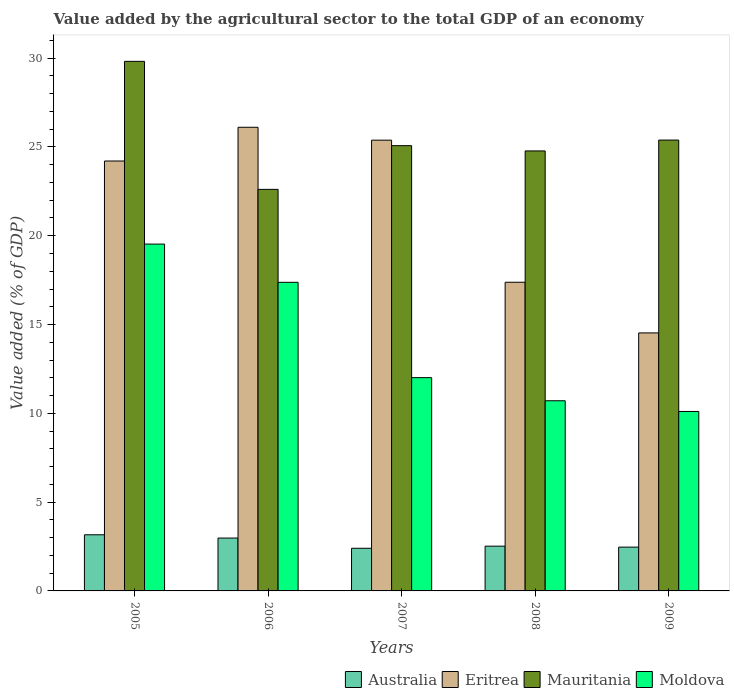How many different coloured bars are there?
Your response must be concise. 4. How many groups of bars are there?
Provide a short and direct response. 5. How many bars are there on the 5th tick from the left?
Offer a very short reply. 4. How many bars are there on the 2nd tick from the right?
Your answer should be very brief. 4. What is the label of the 4th group of bars from the left?
Your answer should be compact. 2008. What is the value added by the agricultural sector to the total GDP in Eritrea in 2005?
Your answer should be very brief. 24.21. Across all years, what is the maximum value added by the agricultural sector to the total GDP in Australia?
Make the answer very short. 3.16. Across all years, what is the minimum value added by the agricultural sector to the total GDP in Mauritania?
Keep it short and to the point. 22.61. In which year was the value added by the agricultural sector to the total GDP in Eritrea minimum?
Ensure brevity in your answer.  2009. What is the total value added by the agricultural sector to the total GDP in Moldova in the graph?
Your response must be concise. 69.73. What is the difference between the value added by the agricultural sector to the total GDP in Eritrea in 2007 and that in 2009?
Your answer should be compact. 10.85. What is the difference between the value added by the agricultural sector to the total GDP in Australia in 2008 and the value added by the agricultural sector to the total GDP in Moldova in 2005?
Provide a short and direct response. -17.01. What is the average value added by the agricultural sector to the total GDP in Australia per year?
Provide a short and direct response. 2.71. In the year 2009, what is the difference between the value added by the agricultural sector to the total GDP in Eritrea and value added by the agricultural sector to the total GDP in Moldova?
Your answer should be compact. 4.42. In how many years, is the value added by the agricultural sector to the total GDP in Australia greater than 15 %?
Your response must be concise. 0. What is the ratio of the value added by the agricultural sector to the total GDP in Moldova in 2007 to that in 2009?
Give a very brief answer. 1.19. Is the value added by the agricultural sector to the total GDP in Mauritania in 2007 less than that in 2008?
Your answer should be compact. No. What is the difference between the highest and the second highest value added by the agricultural sector to the total GDP in Eritrea?
Keep it short and to the point. 0.73. What is the difference between the highest and the lowest value added by the agricultural sector to the total GDP in Moldova?
Provide a short and direct response. 9.43. In how many years, is the value added by the agricultural sector to the total GDP in Australia greater than the average value added by the agricultural sector to the total GDP in Australia taken over all years?
Offer a terse response. 2. What does the 2nd bar from the left in 2007 represents?
Offer a very short reply. Eritrea. What does the 3rd bar from the right in 2005 represents?
Your answer should be very brief. Eritrea. Is it the case that in every year, the sum of the value added by the agricultural sector to the total GDP in Eritrea and value added by the agricultural sector to the total GDP in Australia is greater than the value added by the agricultural sector to the total GDP in Moldova?
Your response must be concise. Yes. What is the difference between two consecutive major ticks on the Y-axis?
Your response must be concise. 5. Does the graph contain grids?
Ensure brevity in your answer.  No. Where does the legend appear in the graph?
Ensure brevity in your answer.  Bottom right. How are the legend labels stacked?
Your answer should be very brief. Horizontal. What is the title of the graph?
Give a very brief answer. Value added by the agricultural sector to the total GDP of an economy. Does "Liechtenstein" appear as one of the legend labels in the graph?
Your response must be concise. No. What is the label or title of the Y-axis?
Make the answer very short. Value added (% of GDP). What is the Value added (% of GDP) in Australia in 2005?
Your response must be concise. 3.16. What is the Value added (% of GDP) in Eritrea in 2005?
Your answer should be compact. 24.21. What is the Value added (% of GDP) of Mauritania in 2005?
Your answer should be compact. 29.82. What is the Value added (% of GDP) of Moldova in 2005?
Your answer should be compact. 19.53. What is the Value added (% of GDP) in Australia in 2006?
Provide a short and direct response. 2.98. What is the Value added (% of GDP) of Eritrea in 2006?
Give a very brief answer. 26.11. What is the Value added (% of GDP) in Mauritania in 2006?
Provide a succinct answer. 22.61. What is the Value added (% of GDP) in Moldova in 2006?
Keep it short and to the point. 17.38. What is the Value added (% of GDP) of Australia in 2007?
Keep it short and to the point. 2.4. What is the Value added (% of GDP) in Eritrea in 2007?
Provide a short and direct response. 25.38. What is the Value added (% of GDP) in Mauritania in 2007?
Give a very brief answer. 25.07. What is the Value added (% of GDP) in Moldova in 2007?
Provide a short and direct response. 12.01. What is the Value added (% of GDP) of Australia in 2008?
Keep it short and to the point. 2.52. What is the Value added (% of GDP) in Eritrea in 2008?
Offer a very short reply. 17.38. What is the Value added (% of GDP) in Mauritania in 2008?
Offer a terse response. 24.78. What is the Value added (% of GDP) in Moldova in 2008?
Provide a short and direct response. 10.71. What is the Value added (% of GDP) of Australia in 2009?
Your response must be concise. 2.47. What is the Value added (% of GDP) of Eritrea in 2009?
Offer a very short reply. 14.53. What is the Value added (% of GDP) of Mauritania in 2009?
Provide a short and direct response. 25.39. What is the Value added (% of GDP) in Moldova in 2009?
Your response must be concise. 10.11. Across all years, what is the maximum Value added (% of GDP) in Australia?
Keep it short and to the point. 3.16. Across all years, what is the maximum Value added (% of GDP) of Eritrea?
Offer a terse response. 26.11. Across all years, what is the maximum Value added (% of GDP) of Mauritania?
Make the answer very short. 29.82. Across all years, what is the maximum Value added (% of GDP) in Moldova?
Offer a very short reply. 19.53. Across all years, what is the minimum Value added (% of GDP) of Australia?
Offer a very short reply. 2.4. Across all years, what is the minimum Value added (% of GDP) in Eritrea?
Offer a terse response. 14.53. Across all years, what is the minimum Value added (% of GDP) in Mauritania?
Your response must be concise. 22.61. Across all years, what is the minimum Value added (% of GDP) of Moldova?
Offer a very short reply. 10.11. What is the total Value added (% of GDP) of Australia in the graph?
Your answer should be very brief. 13.53. What is the total Value added (% of GDP) in Eritrea in the graph?
Keep it short and to the point. 107.61. What is the total Value added (% of GDP) of Mauritania in the graph?
Provide a short and direct response. 127.67. What is the total Value added (% of GDP) in Moldova in the graph?
Your answer should be very brief. 69.73. What is the difference between the Value added (% of GDP) in Australia in 2005 and that in 2006?
Provide a succinct answer. 0.18. What is the difference between the Value added (% of GDP) in Eritrea in 2005 and that in 2006?
Offer a terse response. -1.9. What is the difference between the Value added (% of GDP) in Mauritania in 2005 and that in 2006?
Your response must be concise. 7.21. What is the difference between the Value added (% of GDP) in Moldova in 2005 and that in 2006?
Give a very brief answer. 2.15. What is the difference between the Value added (% of GDP) in Australia in 2005 and that in 2007?
Your answer should be compact. 0.76. What is the difference between the Value added (% of GDP) of Eritrea in 2005 and that in 2007?
Offer a terse response. -1.17. What is the difference between the Value added (% of GDP) of Mauritania in 2005 and that in 2007?
Provide a succinct answer. 4.75. What is the difference between the Value added (% of GDP) in Moldova in 2005 and that in 2007?
Make the answer very short. 7.52. What is the difference between the Value added (% of GDP) in Australia in 2005 and that in 2008?
Make the answer very short. 0.64. What is the difference between the Value added (% of GDP) in Eritrea in 2005 and that in 2008?
Your answer should be very brief. 6.83. What is the difference between the Value added (% of GDP) in Mauritania in 2005 and that in 2008?
Make the answer very short. 5.04. What is the difference between the Value added (% of GDP) in Moldova in 2005 and that in 2008?
Provide a succinct answer. 8.82. What is the difference between the Value added (% of GDP) of Australia in 2005 and that in 2009?
Ensure brevity in your answer.  0.69. What is the difference between the Value added (% of GDP) in Eritrea in 2005 and that in 2009?
Give a very brief answer. 9.68. What is the difference between the Value added (% of GDP) of Mauritania in 2005 and that in 2009?
Provide a short and direct response. 4.43. What is the difference between the Value added (% of GDP) in Moldova in 2005 and that in 2009?
Provide a succinct answer. 9.43. What is the difference between the Value added (% of GDP) in Australia in 2006 and that in 2007?
Give a very brief answer. 0.58. What is the difference between the Value added (% of GDP) in Eritrea in 2006 and that in 2007?
Provide a succinct answer. 0.73. What is the difference between the Value added (% of GDP) of Mauritania in 2006 and that in 2007?
Offer a very short reply. -2.46. What is the difference between the Value added (% of GDP) of Moldova in 2006 and that in 2007?
Your answer should be compact. 5.37. What is the difference between the Value added (% of GDP) in Australia in 2006 and that in 2008?
Your answer should be compact. 0.46. What is the difference between the Value added (% of GDP) of Eritrea in 2006 and that in 2008?
Offer a very short reply. 8.73. What is the difference between the Value added (% of GDP) in Mauritania in 2006 and that in 2008?
Give a very brief answer. -2.16. What is the difference between the Value added (% of GDP) in Moldova in 2006 and that in 2008?
Keep it short and to the point. 6.67. What is the difference between the Value added (% of GDP) in Australia in 2006 and that in 2009?
Provide a succinct answer. 0.51. What is the difference between the Value added (% of GDP) of Eritrea in 2006 and that in 2009?
Offer a terse response. 11.58. What is the difference between the Value added (% of GDP) of Mauritania in 2006 and that in 2009?
Provide a succinct answer. -2.78. What is the difference between the Value added (% of GDP) in Moldova in 2006 and that in 2009?
Your answer should be compact. 7.27. What is the difference between the Value added (% of GDP) of Australia in 2007 and that in 2008?
Provide a short and direct response. -0.12. What is the difference between the Value added (% of GDP) in Eritrea in 2007 and that in 2008?
Your answer should be compact. 8. What is the difference between the Value added (% of GDP) of Mauritania in 2007 and that in 2008?
Your response must be concise. 0.3. What is the difference between the Value added (% of GDP) in Moldova in 2007 and that in 2008?
Ensure brevity in your answer.  1.3. What is the difference between the Value added (% of GDP) of Australia in 2007 and that in 2009?
Your answer should be compact. -0.07. What is the difference between the Value added (% of GDP) of Eritrea in 2007 and that in 2009?
Give a very brief answer. 10.85. What is the difference between the Value added (% of GDP) in Mauritania in 2007 and that in 2009?
Provide a short and direct response. -0.32. What is the difference between the Value added (% of GDP) in Moldova in 2007 and that in 2009?
Provide a short and direct response. 1.9. What is the difference between the Value added (% of GDP) in Australia in 2008 and that in 2009?
Your response must be concise. 0.05. What is the difference between the Value added (% of GDP) in Eritrea in 2008 and that in 2009?
Keep it short and to the point. 2.85. What is the difference between the Value added (% of GDP) in Mauritania in 2008 and that in 2009?
Your answer should be very brief. -0.61. What is the difference between the Value added (% of GDP) of Moldova in 2008 and that in 2009?
Your response must be concise. 0.6. What is the difference between the Value added (% of GDP) in Australia in 2005 and the Value added (% of GDP) in Eritrea in 2006?
Provide a short and direct response. -22.95. What is the difference between the Value added (% of GDP) of Australia in 2005 and the Value added (% of GDP) of Mauritania in 2006?
Provide a short and direct response. -19.45. What is the difference between the Value added (% of GDP) of Australia in 2005 and the Value added (% of GDP) of Moldova in 2006?
Offer a terse response. -14.22. What is the difference between the Value added (% of GDP) in Eritrea in 2005 and the Value added (% of GDP) in Mauritania in 2006?
Offer a very short reply. 1.6. What is the difference between the Value added (% of GDP) of Eritrea in 2005 and the Value added (% of GDP) of Moldova in 2006?
Your answer should be compact. 6.83. What is the difference between the Value added (% of GDP) of Mauritania in 2005 and the Value added (% of GDP) of Moldova in 2006?
Keep it short and to the point. 12.44. What is the difference between the Value added (% of GDP) in Australia in 2005 and the Value added (% of GDP) in Eritrea in 2007?
Offer a very short reply. -22.22. What is the difference between the Value added (% of GDP) in Australia in 2005 and the Value added (% of GDP) in Mauritania in 2007?
Your answer should be very brief. -21.91. What is the difference between the Value added (% of GDP) of Australia in 2005 and the Value added (% of GDP) of Moldova in 2007?
Make the answer very short. -8.85. What is the difference between the Value added (% of GDP) of Eritrea in 2005 and the Value added (% of GDP) of Mauritania in 2007?
Give a very brief answer. -0.86. What is the difference between the Value added (% of GDP) in Eritrea in 2005 and the Value added (% of GDP) in Moldova in 2007?
Give a very brief answer. 12.2. What is the difference between the Value added (% of GDP) of Mauritania in 2005 and the Value added (% of GDP) of Moldova in 2007?
Provide a succinct answer. 17.81. What is the difference between the Value added (% of GDP) of Australia in 2005 and the Value added (% of GDP) of Eritrea in 2008?
Keep it short and to the point. -14.22. What is the difference between the Value added (% of GDP) of Australia in 2005 and the Value added (% of GDP) of Mauritania in 2008?
Provide a succinct answer. -21.62. What is the difference between the Value added (% of GDP) in Australia in 2005 and the Value added (% of GDP) in Moldova in 2008?
Your answer should be very brief. -7.55. What is the difference between the Value added (% of GDP) of Eritrea in 2005 and the Value added (% of GDP) of Mauritania in 2008?
Your response must be concise. -0.57. What is the difference between the Value added (% of GDP) in Eritrea in 2005 and the Value added (% of GDP) in Moldova in 2008?
Provide a short and direct response. 13.5. What is the difference between the Value added (% of GDP) in Mauritania in 2005 and the Value added (% of GDP) in Moldova in 2008?
Give a very brief answer. 19.11. What is the difference between the Value added (% of GDP) of Australia in 2005 and the Value added (% of GDP) of Eritrea in 2009?
Your answer should be compact. -11.37. What is the difference between the Value added (% of GDP) of Australia in 2005 and the Value added (% of GDP) of Mauritania in 2009?
Your response must be concise. -22.23. What is the difference between the Value added (% of GDP) in Australia in 2005 and the Value added (% of GDP) in Moldova in 2009?
Make the answer very short. -6.94. What is the difference between the Value added (% of GDP) of Eritrea in 2005 and the Value added (% of GDP) of Mauritania in 2009?
Keep it short and to the point. -1.18. What is the difference between the Value added (% of GDP) in Eritrea in 2005 and the Value added (% of GDP) in Moldova in 2009?
Ensure brevity in your answer.  14.1. What is the difference between the Value added (% of GDP) of Mauritania in 2005 and the Value added (% of GDP) of Moldova in 2009?
Ensure brevity in your answer.  19.72. What is the difference between the Value added (% of GDP) in Australia in 2006 and the Value added (% of GDP) in Eritrea in 2007?
Provide a short and direct response. -22.41. What is the difference between the Value added (% of GDP) of Australia in 2006 and the Value added (% of GDP) of Mauritania in 2007?
Keep it short and to the point. -22.1. What is the difference between the Value added (% of GDP) in Australia in 2006 and the Value added (% of GDP) in Moldova in 2007?
Your response must be concise. -9.03. What is the difference between the Value added (% of GDP) of Eritrea in 2006 and the Value added (% of GDP) of Mauritania in 2007?
Offer a terse response. 1.04. What is the difference between the Value added (% of GDP) of Eritrea in 2006 and the Value added (% of GDP) of Moldova in 2007?
Give a very brief answer. 14.1. What is the difference between the Value added (% of GDP) in Mauritania in 2006 and the Value added (% of GDP) in Moldova in 2007?
Your response must be concise. 10.6. What is the difference between the Value added (% of GDP) in Australia in 2006 and the Value added (% of GDP) in Eritrea in 2008?
Your response must be concise. -14.41. What is the difference between the Value added (% of GDP) of Australia in 2006 and the Value added (% of GDP) of Mauritania in 2008?
Give a very brief answer. -21.8. What is the difference between the Value added (% of GDP) in Australia in 2006 and the Value added (% of GDP) in Moldova in 2008?
Keep it short and to the point. -7.73. What is the difference between the Value added (% of GDP) in Eritrea in 2006 and the Value added (% of GDP) in Mauritania in 2008?
Provide a short and direct response. 1.33. What is the difference between the Value added (% of GDP) in Eritrea in 2006 and the Value added (% of GDP) in Moldova in 2008?
Your answer should be very brief. 15.4. What is the difference between the Value added (% of GDP) of Mauritania in 2006 and the Value added (% of GDP) of Moldova in 2008?
Ensure brevity in your answer.  11.9. What is the difference between the Value added (% of GDP) in Australia in 2006 and the Value added (% of GDP) in Eritrea in 2009?
Provide a succinct answer. -11.55. What is the difference between the Value added (% of GDP) of Australia in 2006 and the Value added (% of GDP) of Mauritania in 2009?
Keep it short and to the point. -22.41. What is the difference between the Value added (% of GDP) in Australia in 2006 and the Value added (% of GDP) in Moldova in 2009?
Make the answer very short. -7.13. What is the difference between the Value added (% of GDP) of Eritrea in 2006 and the Value added (% of GDP) of Mauritania in 2009?
Give a very brief answer. 0.72. What is the difference between the Value added (% of GDP) of Eritrea in 2006 and the Value added (% of GDP) of Moldova in 2009?
Ensure brevity in your answer.  16. What is the difference between the Value added (% of GDP) of Mauritania in 2006 and the Value added (% of GDP) of Moldova in 2009?
Provide a short and direct response. 12.51. What is the difference between the Value added (% of GDP) of Australia in 2007 and the Value added (% of GDP) of Eritrea in 2008?
Provide a succinct answer. -14.98. What is the difference between the Value added (% of GDP) of Australia in 2007 and the Value added (% of GDP) of Mauritania in 2008?
Provide a short and direct response. -22.38. What is the difference between the Value added (% of GDP) of Australia in 2007 and the Value added (% of GDP) of Moldova in 2008?
Ensure brevity in your answer.  -8.31. What is the difference between the Value added (% of GDP) of Eritrea in 2007 and the Value added (% of GDP) of Mauritania in 2008?
Your answer should be compact. 0.61. What is the difference between the Value added (% of GDP) of Eritrea in 2007 and the Value added (% of GDP) of Moldova in 2008?
Give a very brief answer. 14.68. What is the difference between the Value added (% of GDP) of Mauritania in 2007 and the Value added (% of GDP) of Moldova in 2008?
Your answer should be very brief. 14.37. What is the difference between the Value added (% of GDP) of Australia in 2007 and the Value added (% of GDP) of Eritrea in 2009?
Offer a very short reply. -12.13. What is the difference between the Value added (% of GDP) of Australia in 2007 and the Value added (% of GDP) of Mauritania in 2009?
Provide a succinct answer. -22.99. What is the difference between the Value added (% of GDP) of Australia in 2007 and the Value added (% of GDP) of Moldova in 2009?
Ensure brevity in your answer.  -7.7. What is the difference between the Value added (% of GDP) of Eritrea in 2007 and the Value added (% of GDP) of Mauritania in 2009?
Give a very brief answer. -0. What is the difference between the Value added (% of GDP) in Eritrea in 2007 and the Value added (% of GDP) in Moldova in 2009?
Offer a terse response. 15.28. What is the difference between the Value added (% of GDP) of Mauritania in 2007 and the Value added (% of GDP) of Moldova in 2009?
Provide a short and direct response. 14.97. What is the difference between the Value added (% of GDP) of Australia in 2008 and the Value added (% of GDP) of Eritrea in 2009?
Offer a very short reply. -12.01. What is the difference between the Value added (% of GDP) in Australia in 2008 and the Value added (% of GDP) in Mauritania in 2009?
Offer a terse response. -22.87. What is the difference between the Value added (% of GDP) of Australia in 2008 and the Value added (% of GDP) of Moldova in 2009?
Give a very brief answer. -7.59. What is the difference between the Value added (% of GDP) in Eritrea in 2008 and the Value added (% of GDP) in Mauritania in 2009?
Offer a very short reply. -8.01. What is the difference between the Value added (% of GDP) in Eritrea in 2008 and the Value added (% of GDP) in Moldova in 2009?
Keep it short and to the point. 7.28. What is the difference between the Value added (% of GDP) of Mauritania in 2008 and the Value added (% of GDP) of Moldova in 2009?
Offer a very short reply. 14.67. What is the average Value added (% of GDP) in Australia per year?
Keep it short and to the point. 2.71. What is the average Value added (% of GDP) in Eritrea per year?
Make the answer very short. 21.52. What is the average Value added (% of GDP) of Mauritania per year?
Provide a short and direct response. 25.53. What is the average Value added (% of GDP) of Moldova per year?
Provide a short and direct response. 13.95. In the year 2005, what is the difference between the Value added (% of GDP) of Australia and Value added (% of GDP) of Eritrea?
Your answer should be very brief. -21.05. In the year 2005, what is the difference between the Value added (% of GDP) in Australia and Value added (% of GDP) in Mauritania?
Your answer should be very brief. -26.66. In the year 2005, what is the difference between the Value added (% of GDP) in Australia and Value added (% of GDP) in Moldova?
Your response must be concise. -16.37. In the year 2005, what is the difference between the Value added (% of GDP) of Eritrea and Value added (% of GDP) of Mauritania?
Your answer should be compact. -5.61. In the year 2005, what is the difference between the Value added (% of GDP) of Eritrea and Value added (% of GDP) of Moldova?
Provide a succinct answer. 4.68. In the year 2005, what is the difference between the Value added (% of GDP) in Mauritania and Value added (% of GDP) in Moldova?
Your answer should be very brief. 10.29. In the year 2006, what is the difference between the Value added (% of GDP) of Australia and Value added (% of GDP) of Eritrea?
Your response must be concise. -23.13. In the year 2006, what is the difference between the Value added (% of GDP) in Australia and Value added (% of GDP) in Mauritania?
Keep it short and to the point. -19.64. In the year 2006, what is the difference between the Value added (% of GDP) in Australia and Value added (% of GDP) in Moldova?
Offer a very short reply. -14.4. In the year 2006, what is the difference between the Value added (% of GDP) in Eritrea and Value added (% of GDP) in Mauritania?
Your answer should be very brief. 3.5. In the year 2006, what is the difference between the Value added (% of GDP) of Eritrea and Value added (% of GDP) of Moldova?
Provide a succinct answer. 8.73. In the year 2006, what is the difference between the Value added (% of GDP) of Mauritania and Value added (% of GDP) of Moldova?
Make the answer very short. 5.23. In the year 2007, what is the difference between the Value added (% of GDP) of Australia and Value added (% of GDP) of Eritrea?
Ensure brevity in your answer.  -22.98. In the year 2007, what is the difference between the Value added (% of GDP) of Australia and Value added (% of GDP) of Mauritania?
Offer a terse response. -22.67. In the year 2007, what is the difference between the Value added (% of GDP) of Australia and Value added (% of GDP) of Moldova?
Provide a short and direct response. -9.61. In the year 2007, what is the difference between the Value added (% of GDP) in Eritrea and Value added (% of GDP) in Mauritania?
Provide a short and direct response. 0.31. In the year 2007, what is the difference between the Value added (% of GDP) in Eritrea and Value added (% of GDP) in Moldova?
Provide a succinct answer. 13.37. In the year 2007, what is the difference between the Value added (% of GDP) in Mauritania and Value added (% of GDP) in Moldova?
Ensure brevity in your answer.  13.06. In the year 2008, what is the difference between the Value added (% of GDP) of Australia and Value added (% of GDP) of Eritrea?
Give a very brief answer. -14.86. In the year 2008, what is the difference between the Value added (% of GDP) in Australia and Value added (% of GDP) in Mauritania?
Keep it short and to the point. -22.26. In the year 2008, what is the difference between the Value added (% of GDP) of Australia and Value added (% of GDP) of Moldova?
Keep it short and to the point. -8.19. In the year 2008, what is the difference between the Value added (% of GDP) of Eritrea and Value added (% of GDP) of Mauritania?
Provide a succinct answer. -7.39. In the year 2008, what is the difference between the Value added (% of GDP) in Eritrea and Value added (% of GDP) in Moldova?
Make the answer very short. 6.67. In the year 2008, what is the difference between the Value added (% of GDP) of Mauritania and Value added (% of GDP) of Moldova?
Your response must be concise. 14.07. In the year 2009, what is the difference between the Value added (% of GDP) in Australia and Value added (% of GDP) in Eritrea?
Your answer should be compact. -12.06. In the year 2009, what is the difference between the Value added (% of GDP) of Australia and Value added (% of GDP) of Mauritania?
Your response must be concise. -22.92. In the year 2009, what is the difference between the Value added (% of GDP) of Australia and Value added (% of GDP) of Moldova?
Provide a short and direct response. -7.64. In the year 2009, what is the difference between the Value added (% of GDP) of Eritrea and Value added (% of GDP) of Mauritania?
Your answer should be compact. -10.86. In the year 2009, what is the difference between the Value added (% of GDP) in Eritrea and Value added (% of GDP) in Moldova?
Your answer should be very brief. 4.42. In the year 2009, what is the difference between the Value added (% of GDP) in Mauritania and Value added (% of GDP) in Moldova?
Ensure brevity in your answer.  15.28. What is the ratio of the Value added (% of GDP) of Australia in 2005 to that in 2006?
Offer a terse response. 1.06. What is the ratio of the Value added (% of GDP) in Eritrea in 2005 to that in 2006?
Offer a very short reply. 0.93. What is the ratio of the Value added (% of GDP) in Mauritania in 2005 to that in 2006?
Provide a succinct answer. 1.32. What is the ratio of the Value added (% of GDP) in Moldova in 2005 to that in 2006?
Your answer should be very brief. 1.12. What is the ratio of the Value added (% of GDP) of Australia in 2005 to that in 2007?
Your response must be concise. 1.32. What is the ratio of the Value added (% of GDP) of Eritrea in 2005 to that in 2007?
Ensure brevity in your answer.  0.95. What is the ratio of the Value added (% of GDP) in Mauritania in 2005 to that in 2007?
Make the answer very short. 1.19. What is the ratio of the Value added (% of GDP) of Moldova in 2005 to that in 2007?
Make the answer very short. 1.63. What is the ratio of the Value added (% of GDP) in Australia in 2005 to that in 2008?
Offer a very short reply. 1.25. What is the ratio of the Value added (% of GDP) in Eritrea in 2005 to that in 2008?
Provide a succinct answer. 1.39. What is the ratio of the Value added (% of GDP) of Mauritania in 2005 to that in 2008?
Give a very brief answer. 1.2. What is the ratio of the Value added (% of GDP) of Moldova in 2005 to that in 2008?
Your answer should be very brief. 1.82. What is the ratio of the Value added (% of GDP) of Australia in 2005 to that in 2009?
Offer a very short reply. 1.28. What is the ratio of the Value added (% of GDP) of Eritrea in 2005 to that in 2009?
Keep it short and to the point. 1.67. What is the ratio of the Value added (% of GDP) in Mauritania in 2005 to that in 2009?
Your response must be concise. 1.17. What is the ratio of the Value added (% of GDP) of Moldova in 2005 to that in 2009?
Offer a very short reply. 1.93. What is the ratio of the Value added (% of GDP) in Australia in 2006 to that in 2007?
Offer a terse response. 1.24. What is the ratio of the Value added (% of GDP) of Eritrea in 2006 to that in 2007?
Offer a terse response. 1.03. What is the ratio of the Value added (% of GDP) of Mauritania in 2006 to that in 2007?
Your answer should be very brief. 0.9. What is the ratio of the Value added (% of GDP) in Moldova in 2006 to that in 2007?
Ensure brevity in your answer.  1.45. What is the ratio of the Value added (% of GDP) of Australia in 2006 to that in 2008?
Offer a terse response. 1.18. What is the ratio of the Value added (% of GDP) of Eritrea in 2006 to that in 2008?
Ensure brevity in your answer.  1.5. What is the ratio of the Value added (% of GDP) of Mauritania in 2006 to that in 2008?
Give a very brief answer. 0.91. What is the ratio of the Value added (% of GDP) in Moldova in 2006 to that in 2008?
Your answer should be very brief. 1.62. What is the ratio of the Value added (% of GDP) in Australia in 2006 to that in 2009?
Your response must be concise. 1.21. What is the ratio of the Value added (% of GDP) of Eritrea in 2006 to that in 2009?
Keep it short and to the point. 1.8. What is the ratio of the Value added (% of GDP) in Mauritania in 2006 to that in 2009?
Make the answer very short. 0.89. What is the ratio of the Value added (% of GDP) of Moldova in 2006 to that in 2009?
Give a very brief answer. 1.72. What is the ratio of the Value added (% of GDP) of Australia in 2007 to that in 2008?
Your response must be concise. 0.95. What is the ratio of the Value added (% of GDP) in Eritrea in 2007 to that in 2008?
Provide a succinct answer. 1.46. What is the ratio of the Value added (% of GDP) in Mauritania in 2007 to that in 2008?
Provide a short and direct response. 1.01. What is the ratio of the Value added (% of GDP) in Moldova in 2007 to that in 2008?
Provide a succinct answer. 1.12. What is the ratio of the Value added (% of GDP) in Australia in 2007 to that in 2009?
Your answer should be very brief. 0.97. What is the ratio of the Value added (% of GDP) in Eritrea in 2007 to that in 2009?
Provide a short and direct response. 1.75. What is the ratio of the Value added (% of GDP) in Mauritania in 2007 to that in 2009?
Ensure brevity in your answer.  0.99. What is the ratio of the Value added (% of GDP) in Moldova in 2007 to that in 2009?
Provide a succinct answer. 1.19. What is the ratio of the Value added (% of GDP) in Australia in 2008 to that in 2009?
Make the answer very short. 1.02. What is the ratio of the Value added (% of GDP) of Eritrea in 2008 to that in 2009?
Give a very brief answer. 1.2. What is the ratio of the Value added (% of GDP) of Mauritania in 2008 to that in 2009?
Offer a very short reply. 0.98. What is the ratio of the Value added (% of GDP) in Moldova in 2008 to that in 2009?
Ensure brevity in your answer.  1.06. What is the difference between the highest and the second highest Value added (% of GDP) in Australia?
Provide a short and direct response. 0.18. What is the difference between the highest and the second highest Value added (% of GDP) of Eritrea?
Offer a very short reply. 0.73. What is the difference between the highest and the second highest Value added (% of GDP) in Mauritania?
Your answer should be compact. 4.43. What is the difference between the highest and the second highest Value added (% of GDP) in Moldova?
Offer a very short reply. 2.15. What is the difference between the highest and the lowest Value added (% of GDP) in Australia?
Keep it short and to the point. 0.76. What is the difference between the highest and the lowest Value added (% of GDP) in Eritrea?
Make the answer very short. 11.58. What is the difference between the highest and the lowest Value added (% of GDP) in Mauritania?
Ensure brevity in your answer.  7.21. What is the difference between the highest and the lowest Value added (% of GDP) of Moldova?
Offer a very short reply. 9.43. 